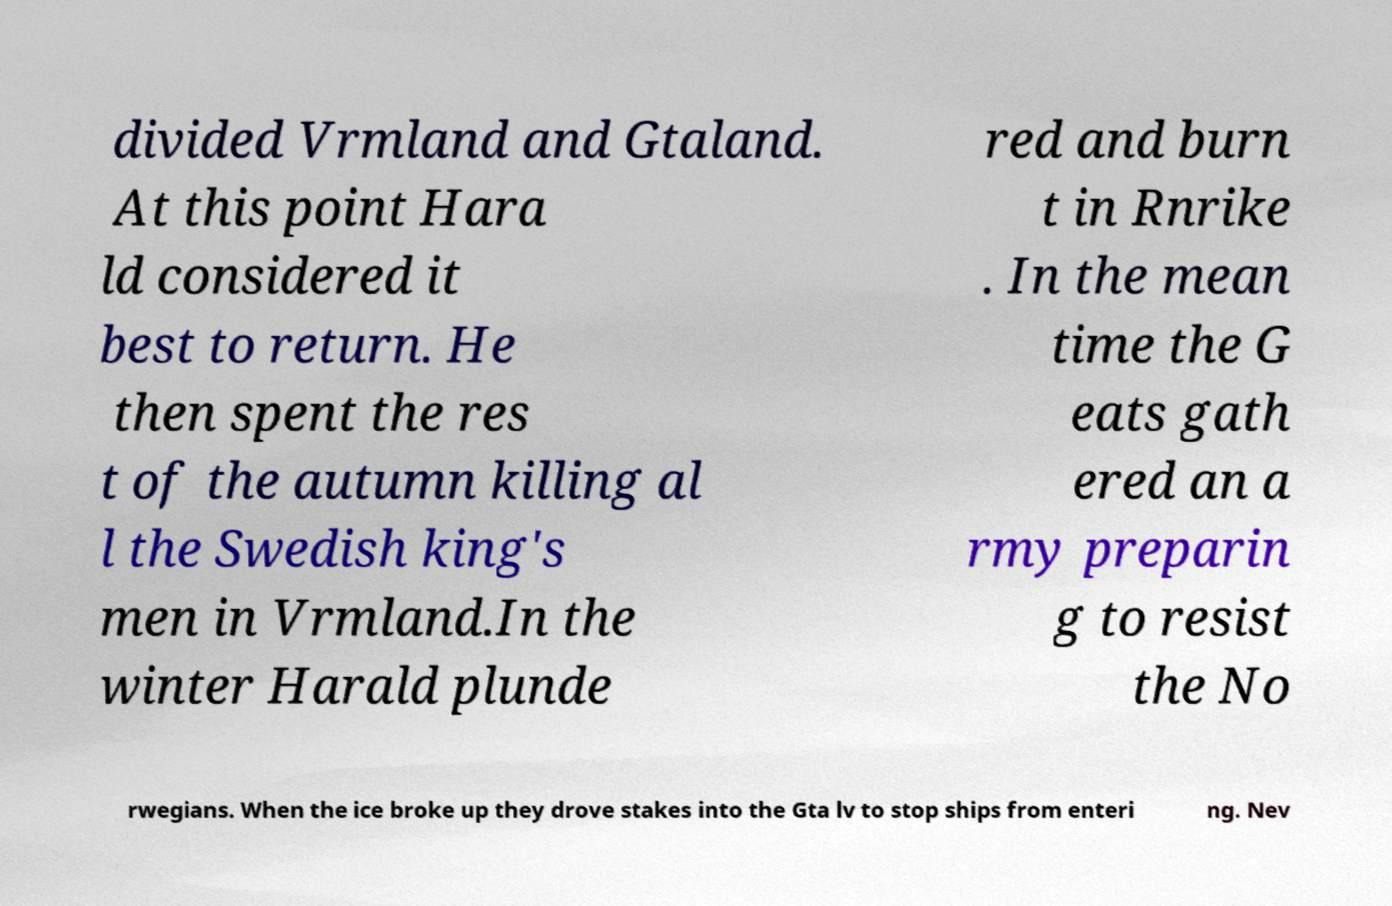Can you accurately transcribe the text from the provided image for me? divided Vrmland and Gtaland. At this point Hara ld considered it best to return. He then spent the res t of the autumn killing al l the Swedish king's men in Vrmland.In the winter Harald plunde red and burn t in Rnrike . In the mean time the G eats gath ered an a rmy preparin g to resist the No rwegians. When the ice broke up they drove stakes into the Gta lv to stop ships from enteri ng. Nev 